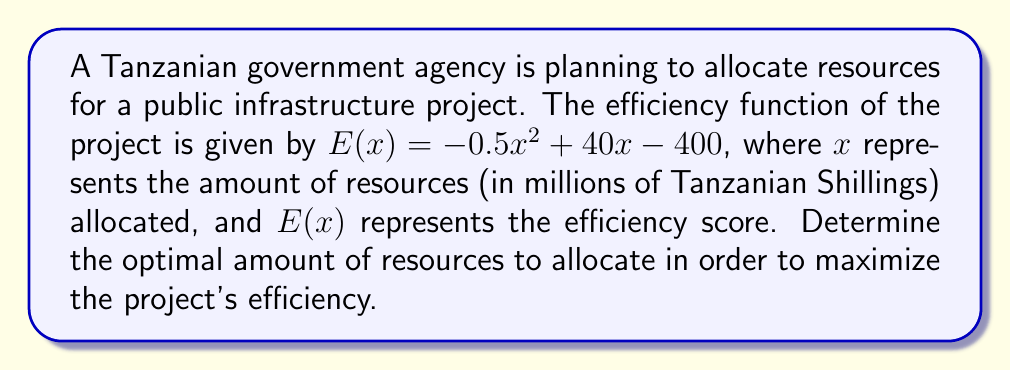Give your solution to this math problem. To find the maximum efficiency point, we need to determine where the derivative of the efficiency function equals zero.

Step 1: Find the derivative of $E(x)$.
$$E'(x) = \frac{d}{dx}(-0.5x^2 + 40x - 400) = -x + 40$$

Step 2: Set the derivative equal to zero and solve for $x$.
$$E'(x) = 0$$
$$-x + 40 = 0$$
$$x = 40$$

Step 3: Verify that this critical point is a maximum by checking the second derivative.
$$E''(x) = \frac{d}{dx}(-x + 40) = -1$$

Since $E''(x)$ is negative, the critical point is a maximum.

Step 4: Calculate the maximum efficiency score by plugging $x = 40$ into the original function.
$$E(40) = -0.5(40)^2 + 40(40) - 400$$
$$= -800 + 1600 - 400$$
$$= 400$$

Therefore, the optimal amount of resources to allocate is 40 million Tanzanian Shillings, which will result in a maximum efficiency score of 400.
Answer: 40 million Tanzanian Shillings 